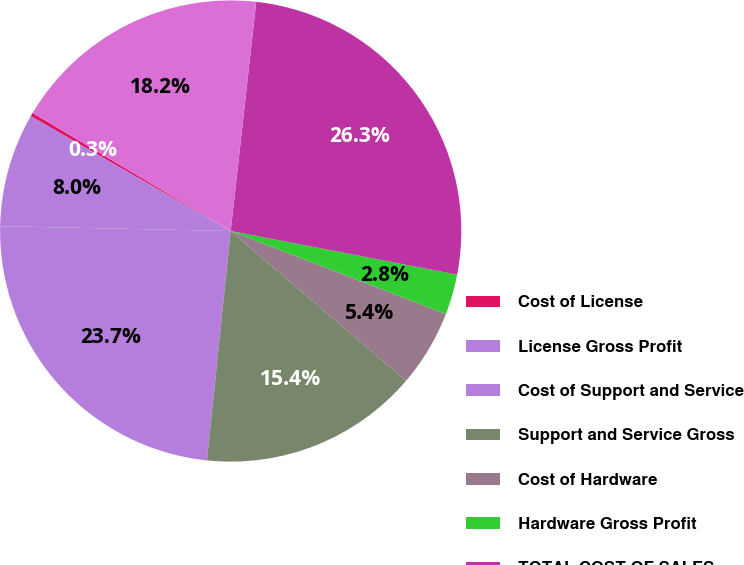<chart> <loc_0><loc_0><loc_500><loc_500><pie_chart><fcel>Cost of License<fcel>License Gross Profit<fcel>Cost of Support and Service<fcel>Support and Service Gross<fcel>Cost of Hardware<fcel>Hardware Gross Profit<fcel>TOTAL COST OF SALES<fcel>TOTAL GROSS PROFIT<nl><fcel>0.26%<fcel>7.96%<fcel>23.69%<fcel>15.38%<fcel>5.4%<fcel>2.83%<fcel>26.26%<fcel>18.21%<nl></chart> 